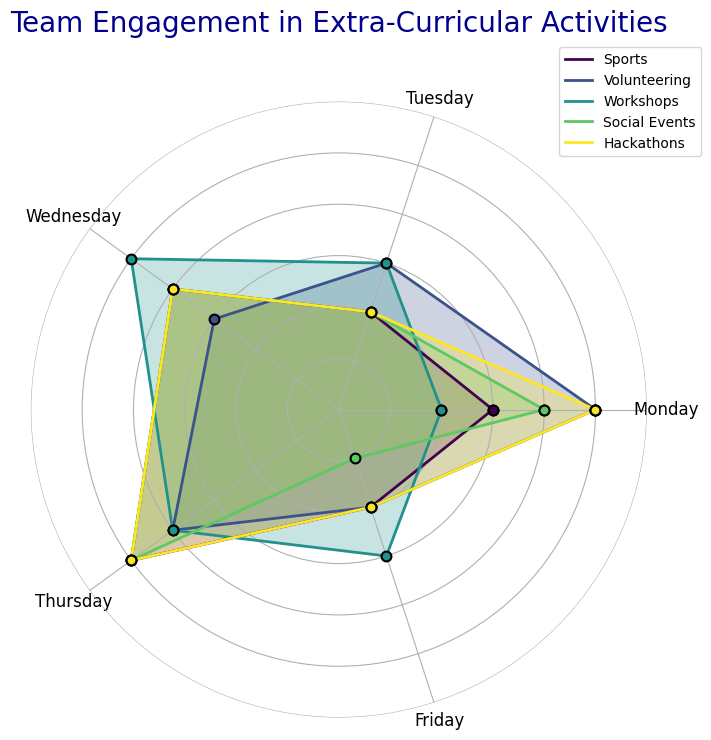What day has the highest engagement in Social Events? The radar chart shows lines representing different activities. The Social Events line is the yellow one, and we see it peaks on five days. By visually checking, Friday has the highest engagement with a value reaching outwards the most.
Answer: Friday Between Sports and Hackathons, which activity has higher engagement on Wednesdays? Looking at the plot, the lines for each activity intersecting the Wednesday axis can be compared. Sports (blue) has a value of 2, and Hackathons (purple) has a value of 3. Therefore, Hackathons have higher engagement.
Answer: Hackathons Which activity shows the most consistent engagement across all days? Consistency can be seen as how similar the values are across all days. Social Events (yellow) appears to have very similar, high values every day, indicating consistent engagement.
Answer: Social Events Compare the average engagement in Workshops and Volunteering over all days. Which is higher? Calculate the average engagement for each. For Workshops: (4+3+5+4+4)/5 = 4. For Volunteering: (2+3+3+2+2)/5 = 2.4. The average engagement in Workshops is higher.
Answer: Workshops Which day has the lowest engagement in Hackathons? The Hackathons line (purple) has the least value on Thursday, where it dips the most towards the center.
Answer: Thursday What is the difference in engagement between Sports and Volunteering on Fridays? Engagement for Sports on Friday is 5 and for Volunteering is 2. The difference is 5 - 2 = 3.
Answer: 3 Compare the engagement in Sports on Monday and Thursday. How much does it increase? Comparing the heights of the Sports line on Monday (3) and Thursday (4), the engagement increases by 4 - 3 = 1.
Answer: 1 What's the total engagement in Workshops across all days? Sum the values for Workshops: 4 (Mon) + 3 (Tue) + 5 (Wed) + 4 (Thu) + 4 (Fri) = 20.
Answer: 20 